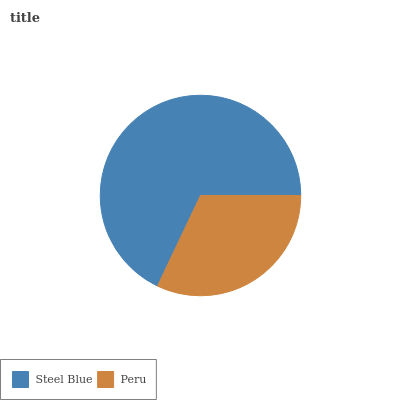Is Peru the minimum?
Answer yes or no. Yes. Is Steel Blue the maximum?
Answer yes or no. Yes. Is Peru the maximum?
Answer yes or no. No. Is Steel Blue greater than Peru?
Answer yes or no. Yes. Is Peru less than Steel Blue?
Answer yes or no. Yes. Is Peru greater than Steel Blue?
Answer yes or no. No. Is Steel Blue less than Peru?
Answer yes or no. No. Is Steel Blue the high median?
Answer yes or no. Yes. Is Peru the low median?
Answer yes or no. Yes. Is Peru the high median?
Answer yes or no. No. Is Steel Blue the low median?
Answer yes or no. No. 